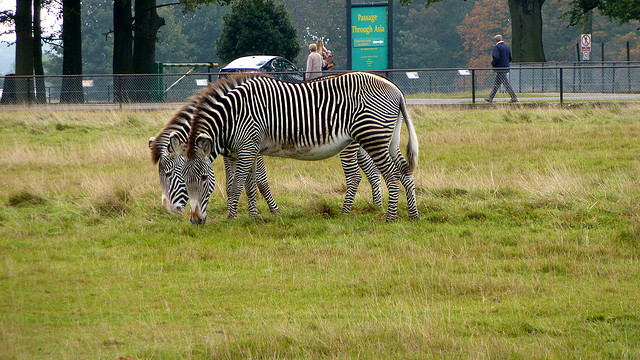Read and extract the text from this image. Passage Through Asia 